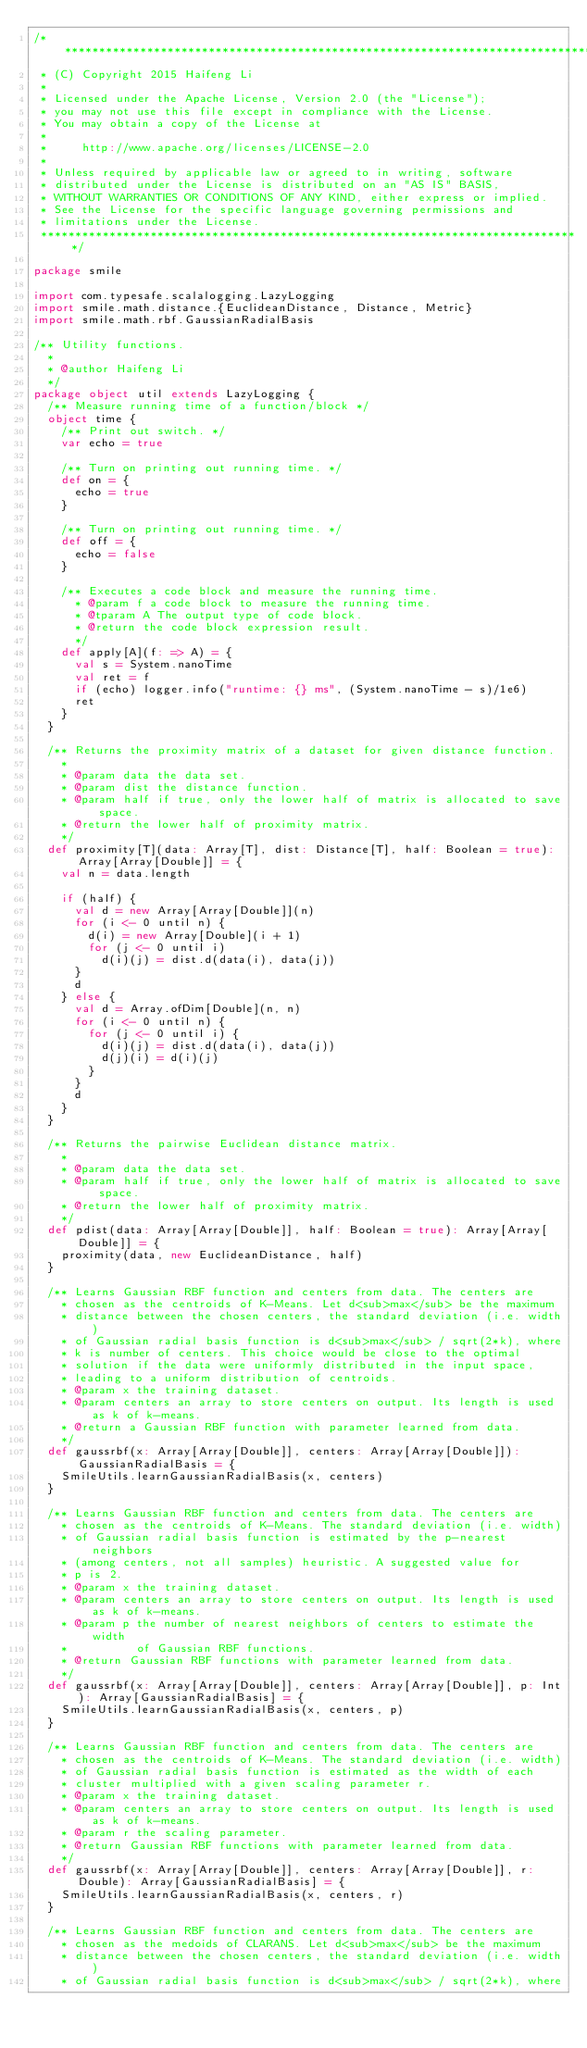<code> <loc_0><loc_0><loc_500><loc_500><_Scala_>/*******************************************************************************
 * (C) Copyright 2015 Haifeng Li
 *
 * Licensed under the Apache License, Version 2.0 (the "License");
 * you may not use this file except in compliance with the License.
 * You may obtain a copy of the License at
 *
 *     http://www.apache.org/licenses/LICENSE-2.0
 *
 * Unless required by applicable law or agreed to in writing, software
 * distributed under the License is distributed on an "AS IS" BASIS,
 * WITHOUT WARRANTIES OR CONDITIONS OF ANY KIND, either express or implied.
 * See the License for the specific language governing permissions and
 * limitations under the License.
 *******************************************************************************/

package smile

import com.typesafe.scalalogging.LazyLogging
import smile.math.distance.{EuclideanDistance, Distance, Metric}
import smile.math.rbf.GaussianRadialBasis

/** Utility functions.
  *
  * @author Haifeng Li
  */
package object util extends LazyLogging {
  /** Measure running time of a function/block */
  object time {
    /** Print out switch. */
    var echo = true

    /** Turn on printing out running time. */
    def on = {
      echo = true
    }

    /** Turn on printing out running time. */
    def off = {
      echo = false
    }

    /** Executes a code block and measure the running time.
      * @param f a code block to measure the running time.
      * @tparam A The output type of code block.
      * @return the code block expression result.
      */
    def apply[A](f: => A) = {
      val s = System.nanoTime
      val ret = f
      if (echo) logger.info("runtime: {} ms", (System.nanoTime - s)/1e6)
      ret
    }
  }

  /** Returns the proximity matrix of a dataset for given distance function.
    *
    * @param data the data set.
    * @param dist the distance function.
    * @param half if true, only the lower half of matrix is allocated to save space.
    * @return the lower half of proximity matrix.
    */
  def proximity[T](data: Array[T], dist: Distance[T], half: Boolean = true): Array[Array[Double]] = {
    val n = data.length

    if (half) {
      val d = new Array[Array[Double]](n)
      for (i <- 0 until n) {
        d(i) = new Array[Double](i + 1)
        for (j <- 0 until i)
          d(i)(j) = dist.d(data(i), data(j))
      }
      d
    } else {
      val d = Array.ofDim[Double](n, n)
      for (i <- 0 until n) {
        for (j <- 0 until i) {
          d(i)(j) = dist.d(data(i), data(j))
          d(j)(i) = d(i)(j)
        }
      }
      d
    }
  }

  /** Returns the pairwise Euclidean distance matrix.
    *
    * @param data the data set.
    * @param half if true, only the lower half of matrix is allocated to save space.
    * @return the lower half of proximity matrix.
    */
  def pdist(data: Array[Array[Double]], half: Boolean = true): Array[Array[Double]] = {
    proximity(data, new EuclideanDistance, half)
  }

  /** Learns Gaussian RBF function and centers from data. The centers are
    * chosen as the centroids of K-Means. Let d<sub>max</sub> be the maximum
    * distance between the chosen centers, the standard deviation (i.e. width)
    * of Gaussian radial basis function is d<sub>max</sub> / sqrt(2*k), where
    * k is number of centers. This choice would be close to the optimal
    * solution if the data were uniformly distributed in the input space,
    * leading to a uniform distribution of centroids.
    * @param x the training dataset.
    * @param centers an array to store centers on output. Its length is used as k of k-means.
    * @return a Gaussian RBF function with parameter learned from data.
    */
  def gaussrbf(x: Array[Array[Double]], centers: Array[Array[Double]]): GaussianRadialBasis = {
    SmileUtils.learnGaussianRadialBasis(x, centers)
  }

  /** Learns Gaussian RBF function and centers from data. The centers are
    * chosen as the centroids of K-Means. The standard deviation (i.e. width)
    * of Gaussian radial basis function is estimated by the p-nearest neighbors
    * (among centers, not all samples) heuristic. A suggested value for
    * p is 2.
    * @param x the training dataset.
    * @param centers an array to store centers on output. Its length is used as k of k-means.
    * @param p the number of nearest neighbors of centers to estimate the width
    *          of Gaussian RBF functions.
    * @return Gaussian RBF functions with parameter learned from data.
    */
  def gaussrbf(x: Array[Array[Double]], centers: Array[Array[Double]], p: Int): Array[GaussianRadialBasis] = {
    SmileUtils.learnGaussianRadialBasis(x, centers, p)
  }

  /** Learns Gaussian RBF function and centers from data. The centers are
    * chosen as the centroids of K-Means. The standard deviation (i.e. width)
    * of Gaussian radial basis function is estimated as the width of each
    * cluster multiplied with a given scaling parameter r.
    * @param x the training dataset.
    * @param centers an array to store centers on output. Its length is used as k of k-means.
    * @param r the scaling parameter.
    * @return Gaussian RBF functions with parameter learned from data.
    */
  def gaussrbf(x: Array[Array[Double]], centers: Array[Array[Double]], r: Double): Array[GaussianRadialBasis] = {
    SmileUtils.learnGaussianRadialBasis(x, centers, r)
  }

  /** Learns Gaussian RBF function and centers from data. The centers are
    * chosen as the medoids of CLARANS. Let d<sub>max</sub> be the maximum
    * distance between the chosen centers, the standard deviation (i.e. width)
    * of Gaussian radial basis function is d<sub>max</sub> / sqrt(2*k), where</code> 